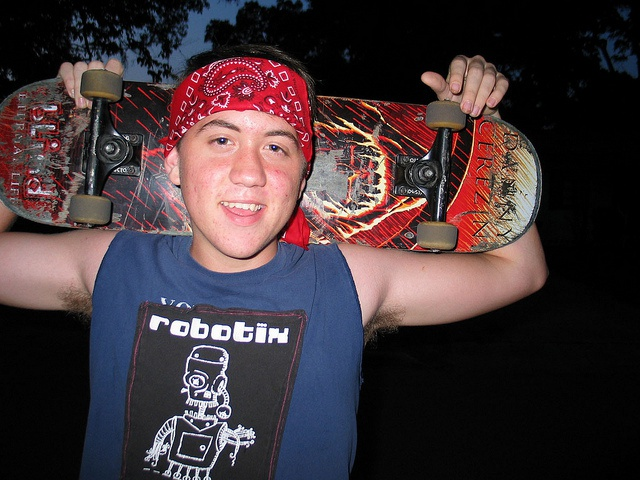Describe the objects in this image and their specific colors. I can see people in black, lightpink, darkblue, and navy tones and skateboard in black, gray, maroon, and darkgray tones in this image. 